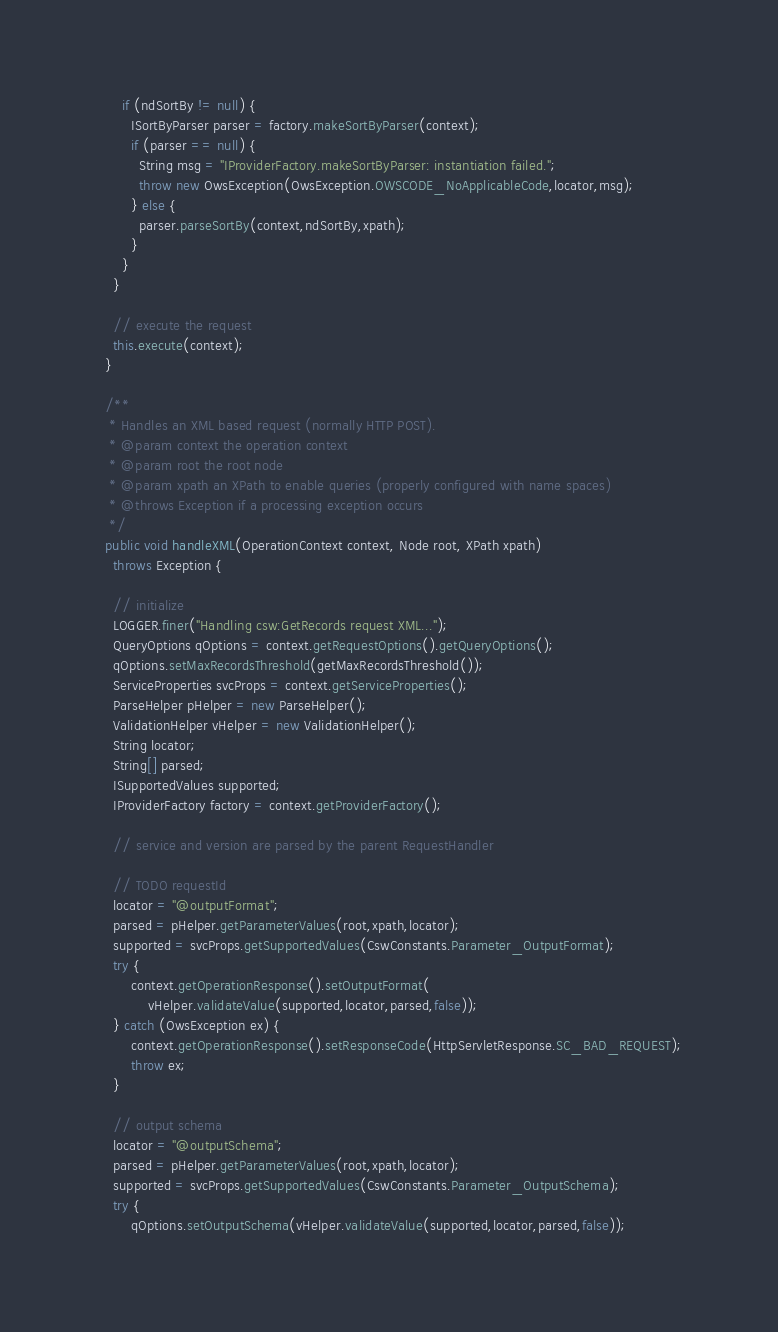Convert code to text. <code><loc_0><loc_0><loc_500><loc_500><_Java_>      if (ndSortBy != null) {
        ISortByParser parser = factory.makeSortByParser(context);
        if (parser == null) {
          String msg = "IProviderFactory.makeSortByParser: instantiation failed.";
          throw new OwsException(OwsException.OWSCODE_NoApplicableCode,locator,msg);
        } else {
          parser.parseSortBy(context,ndSortBy,xpath);
        }
      }
    }
    
    // execute the request
    this.execute(context);
  }

  /**
   * Handles an XML based request (normally HTTP POST).
   * @param context the operation context
   * @param root the root node
   * @param xpath an XPath to enable queries (properly configured with name spaces)
   * @throws Exception if a processing exception occurs
   */
  public void handleXML(OperationContext context, Node root, XPath xpath)
    throws Exception {
    
    // initialize
    LOGGER.finer("Handling csw:GetRecords request XML...");
    QueryOptions qOptions = context.getRequestOptions().getQueryOptions();
    qOptions.setMaxRecordsThreshold(getMaxRecordsThreshold());
    ServiceProperties svcProps = context.getServiceProperties();
    ParseHelper pHelper = new ParseHelper();
    ValidationHelper vHelper = new ValidationHelper();
    String locator;
    String[] parsed;
    ISupportedValues supported;
    IProviderFactory factory = context.getProviderFactory();
    
    // service and version are parsed by the parent RequestHandler
    
    // TODO requestId
    locator = "@outputFormat";
    parsed = pHelper.getParameterValues(root,xpath,locator);
    supported = svcProps.getSupportedValues(CswConstants.Parameter_OutputFormat);
    try {
        context.getOperationResponse().setOutputFormat(
            vHelper.validateValue(supported,locator,parsed,false));
    } catch (OwsException ex) {
        context.getOperationResponse().setResponseCode(HttpServletResponse.SC_BAD_REQUEST);
        throw ex;
    }
        
    // output schema
    locator = "@outputSchema";
    parsed = pHelper.getParameterValues(root,xpath,locator);
    supported = svcProps.getSupportedValues(CswConstants.Parameter_OutputSchema);
    try {
        qOptions.setOutputSchema(vHelper.validateValue(supported,locator,parsed,false));</code> 